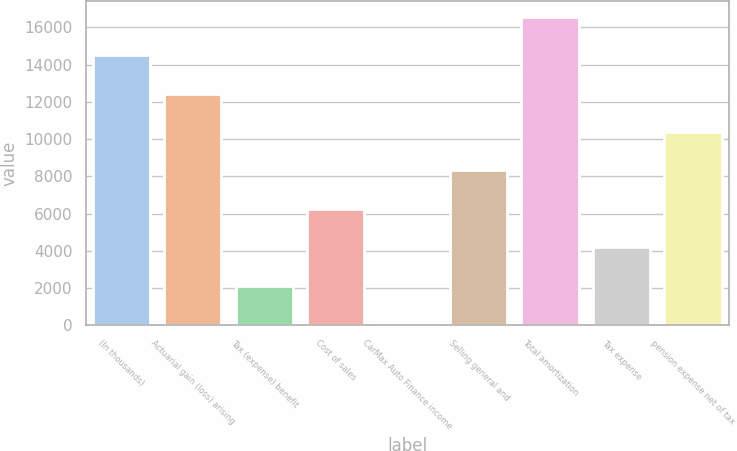<chart> <loc_0><loc_0><loc_500><loc_500><bar_chart><fcel>(In thousands)<fcel>Actuarial gain (loss) arising<fcel>Tax (expense) benefit<fcel>Cost of sales<fcel>CarMax Auto Finance income<fcel>Selling general and<fcel>Total amortization<fcel>Tax expense<fcel>pension expense net of tax<nl><fcel>14515.2<fcel>12448.6<fcel>2115.6<fcel>6248.8<fcel>49<fcel>8315.4<fcel>16581.8<fcel>4182.2<fcel>10382<nl></chart> 